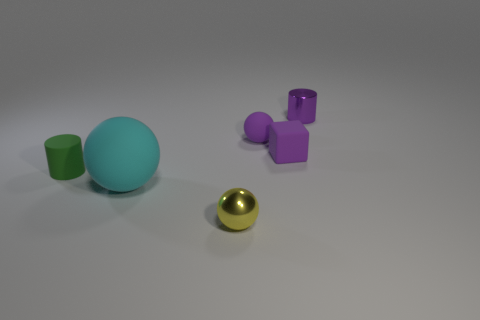Subtract all tiny matte spheres. How many spheres are left? 2 Subtract all yellow spheres. How many spheres are left? 2 Subtract all cylinders. How many objects are left? 4 Add 1 green objects. How many objects exist? 7 Subtract 0 red cylinders. How many objects are left? 6 Subtract 1 blocks. How many blocks are left? 0 Subtract all yellow cubes. Subtract all blue cylinders. How many cubes are left? 1 Subtract all gray balls. How many purple cylinders are left? 1 Subtract all small green rubber cylinders. Subtract all large yellow shiny cubes. How many objects are left? 5 Add 4 small yellow balls. How many small yellow balls are left? 5 